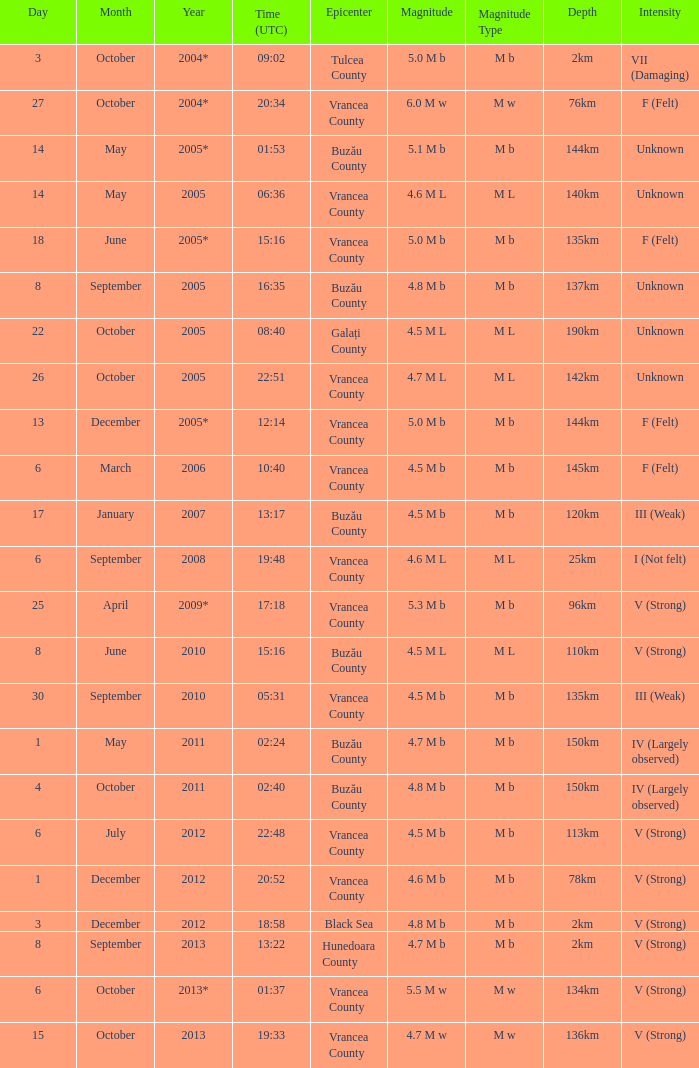Where was the epicenter of the quake on December 1, 2012? Vrancea County. 